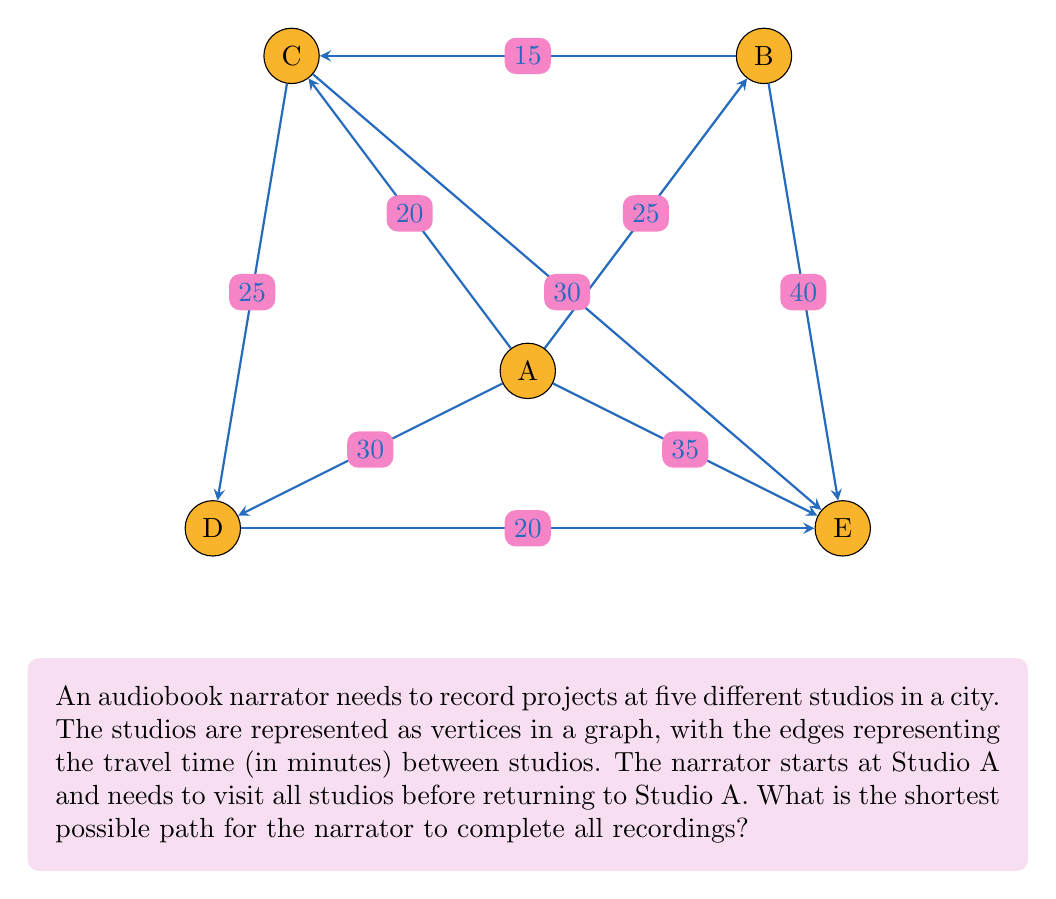Teach me how to tackle this problem. To solve this problem, we need to find the shortest Hamiltonian cycle in the given graph, which is known as the Traveling Salesman Problem (TSP). Since the graph is small, we can use a brute-force approach to find the optimal solution.

Step 1: List all possible permutations of the studios (excluding A, since it's the start and end point).
Permutations: BCDE, BCED, BDCE, BDEC, BECD, BEDC, CBDE, CBED, CDBE, CDEB, CEBD, CEDB, DBCE, DBEC, DCBE, DCEB, DEBC, DECB, EBCD, EBDC, ECBD, ECDB, EDBC, EDCB

Step 2: Calculate the total distance for each permutation, including the distance from A to the first studio and from the last studio back to A.

Step 3: Find the permutation with the minimum total distance.

After calculating all permutations, we find that the shortest path is:

A → C → B → E → D → A

Let's calculate the total distance:
$$\text{Total distance} = AC + CB + BE + ED + DA = 20 + 15 + 40 + 20 + 30 = 125\text{ minutes}$$

This path ensures that the narrator visits all studios while minimizing the total travel time.
Answer: A → C → B → E → D → A, 125 minutes 